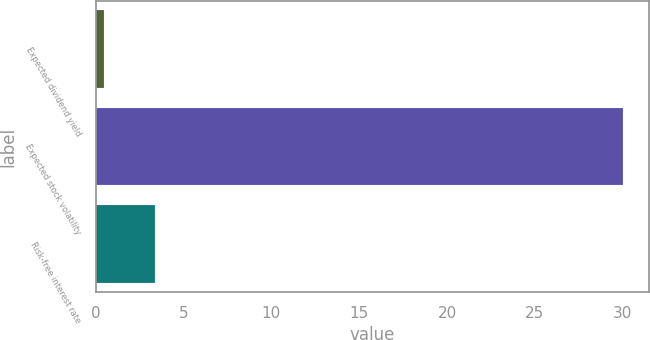Convert chart to OTSL. <chart><loc_0><loc_0><loc_500><loc_500><bar_chart><fcel>Expected dividend yield<fcel>Expected stock volatility<fcel>Risk-free interest rate<nl><fcel>0.46<fcel>30<fcel>3.41<nl></chart> 